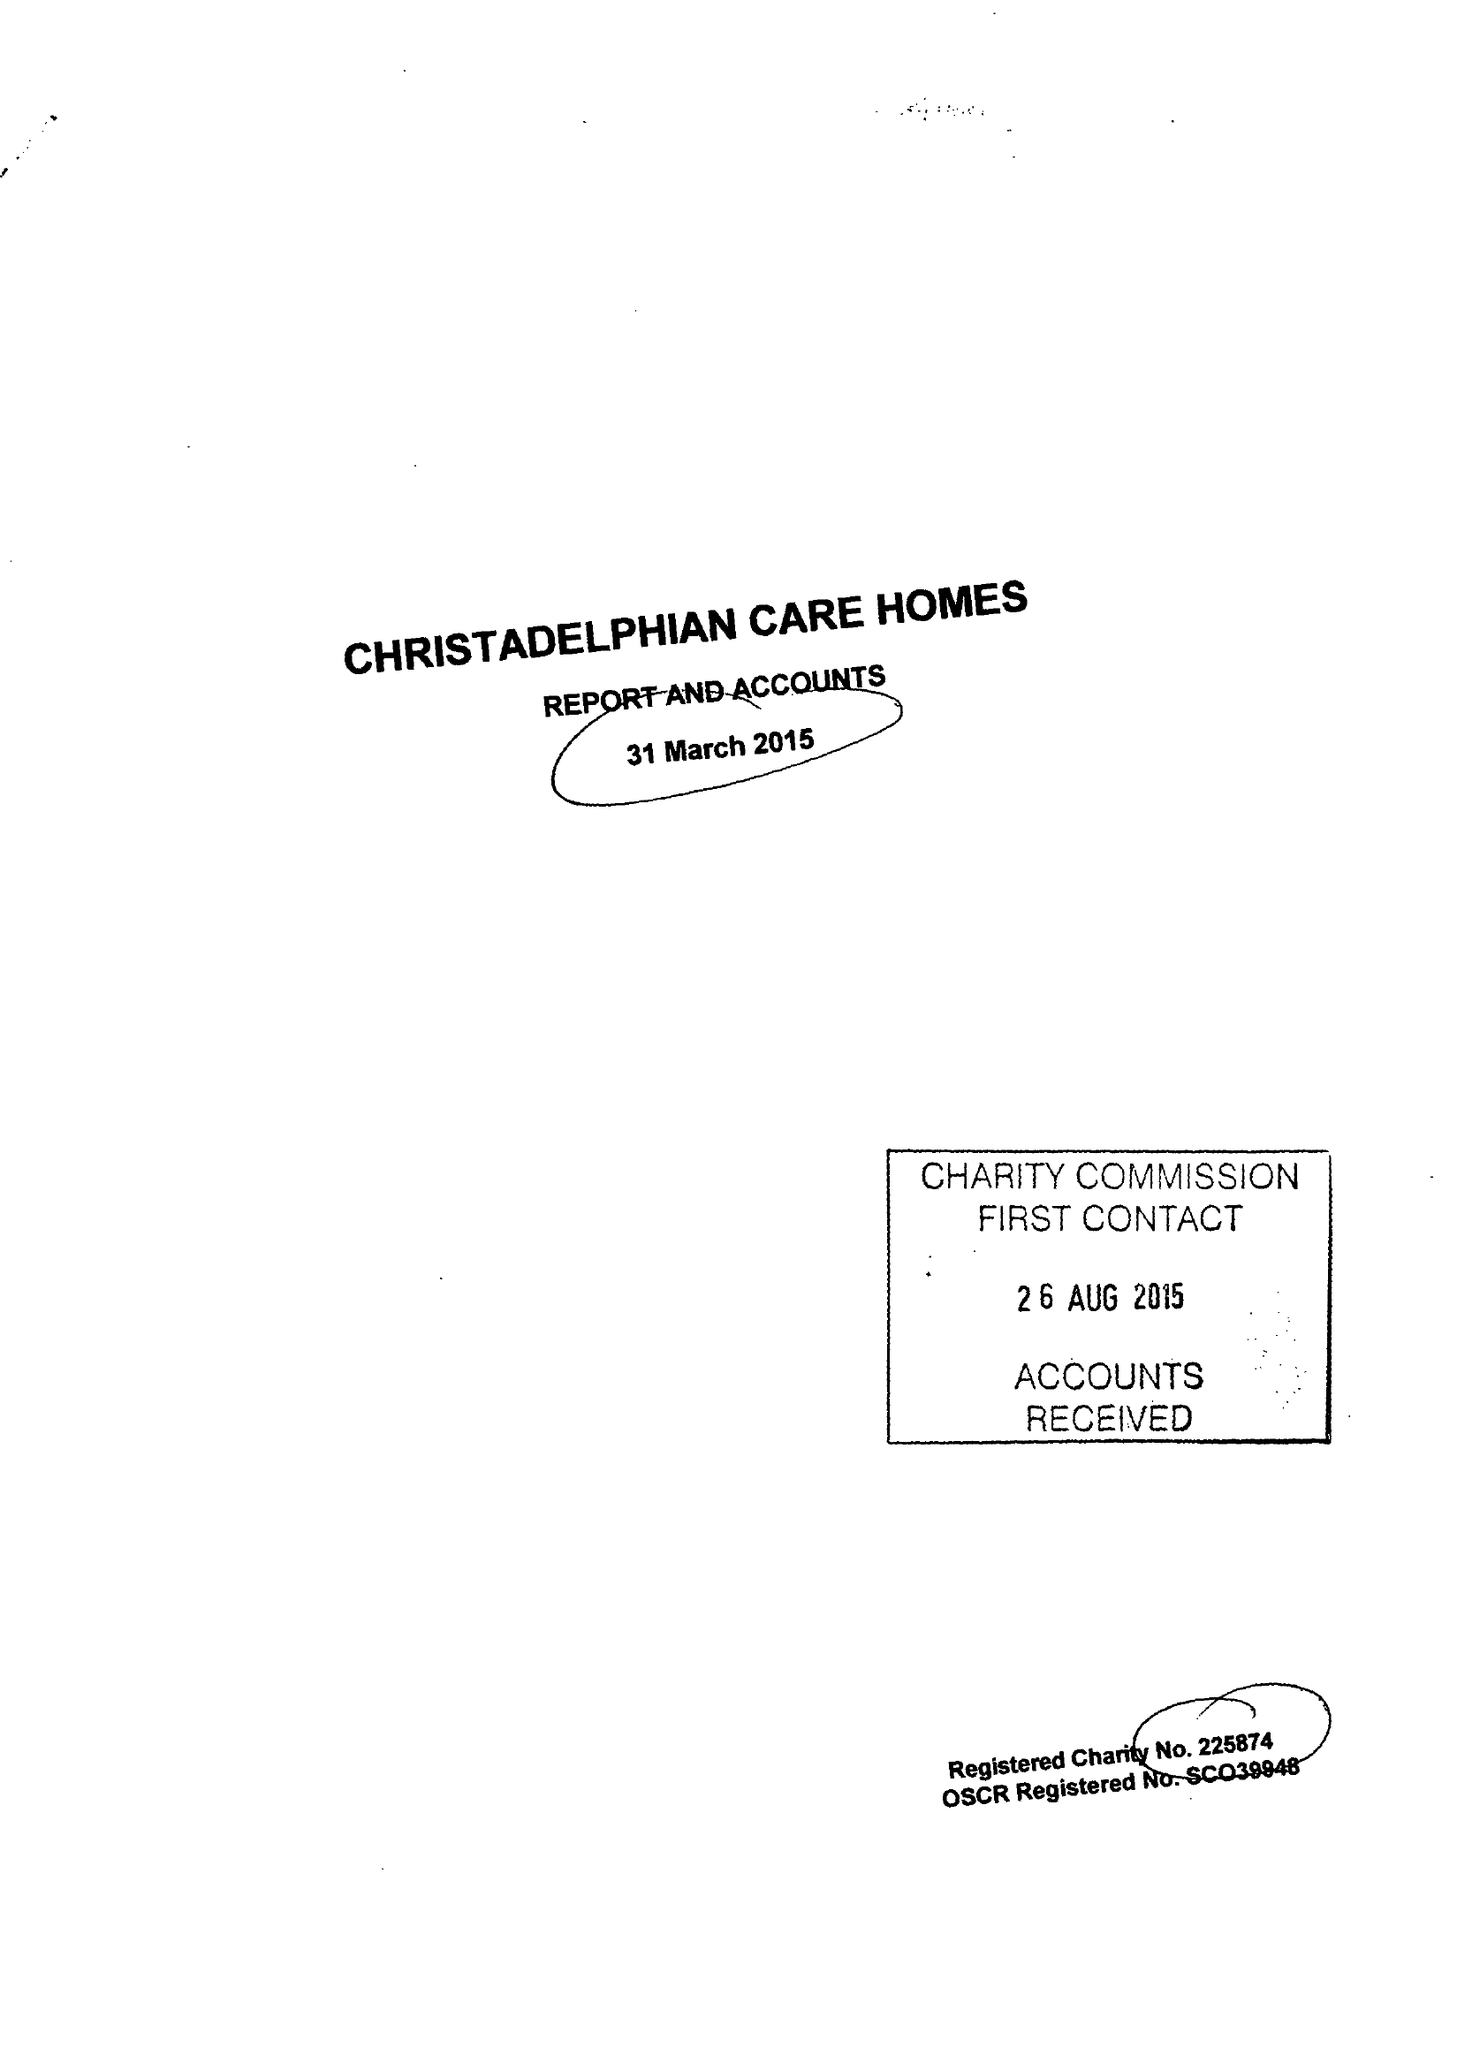What is the value for the income_annually_in_british_pounds?
Answer the question using a single word or phrase. 9383285.00 